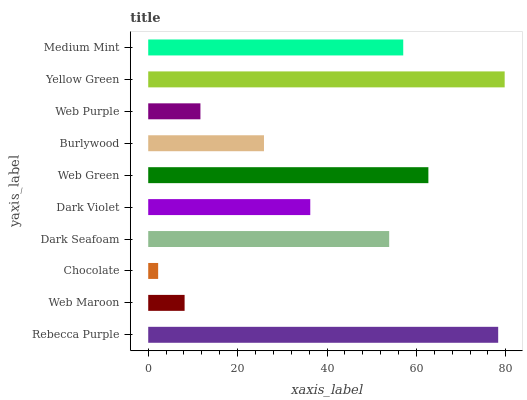Is Chocolate the minimum?
Answer yes or no. Yes. Is Yellow Green the maximum?
Answer yes or no. Yes. Is Web Maroon the minimum?
Answer yes or no. No. Is Web Maroon the maximum?
Answer yes or no. No. Is Rebecca Purple greater than Web Maroon?
Answer yes or no. Yes. Is Web Maroon less than Rebecca Purple?
Answer yes or no. Yes. Is Web Maroon greater than Rebecca Purple?
Answer yes or no. No. Is Rebecca Purple less than Web Maroon?
Answer yes or no. No. Is Dark Seafoam the high median?
Answer yes or no. Yes. Is Dark Violet the low median?
Answer yes or no. Yes. Is Chocolate the high median?
Answer yes or no. No. Is Chocolate the low median?
Answer yes or no. No. 